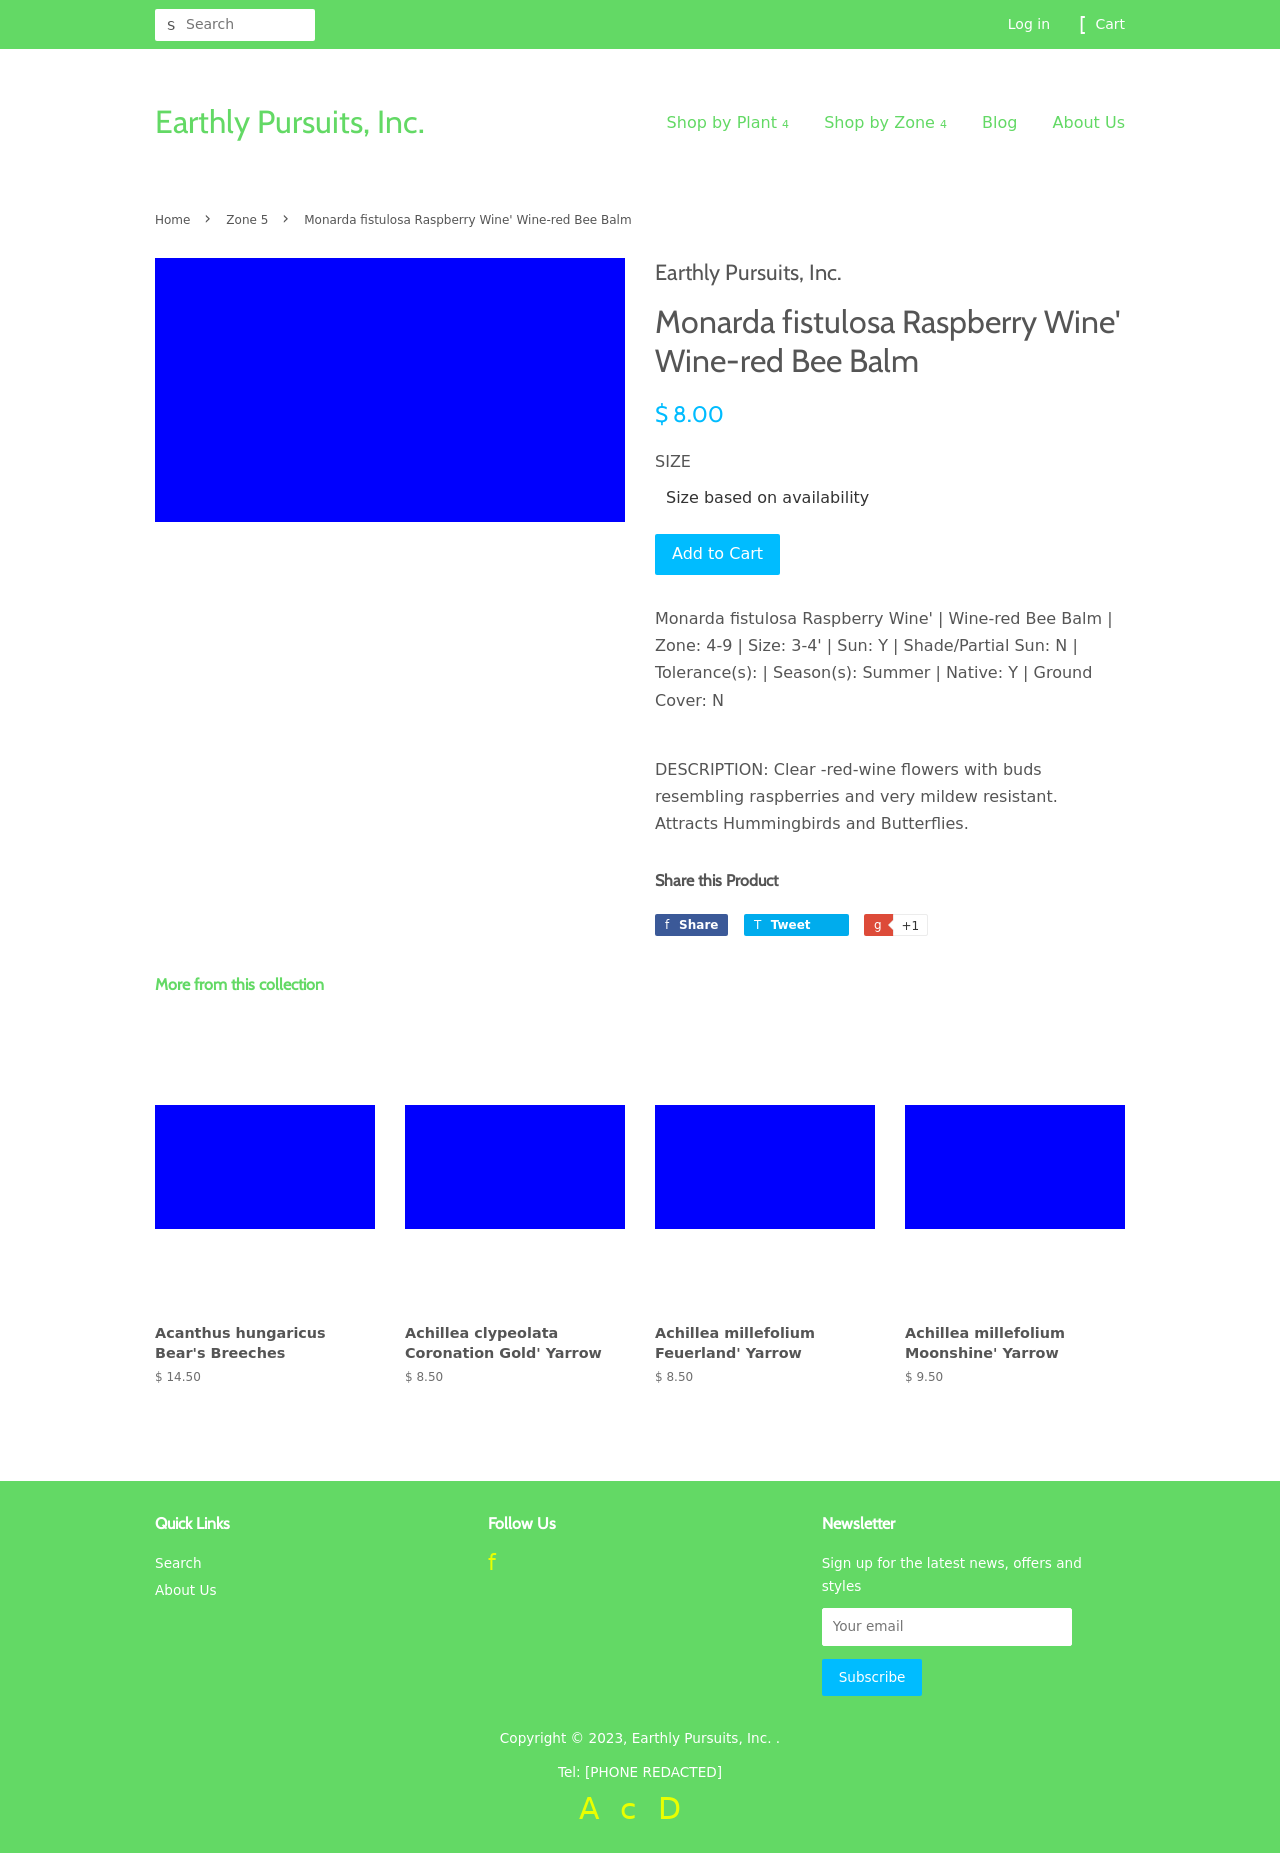Can you describe the product features of 'Monarda fistulosa Raspberry Wine' displayed on this website page? The 'Monarda fistulosa Raspberry Wine' listed on the website is a type of Wine-red Bee Balm, priced at $8.00. This plant, ideal for zones 4-9, grows a size of 3-4 feet (90-120 cm). It prefers sunlight and can tolerate partial sun but not full shade. Notable for its clear red-wine flowers that resemble raspberries, it blooms in the summer, is native to certain regions, and does not provide ground cover. Additionally, it is known for attracting hummingbirds and butterflies due to its vivid flower appearances and nectar. 